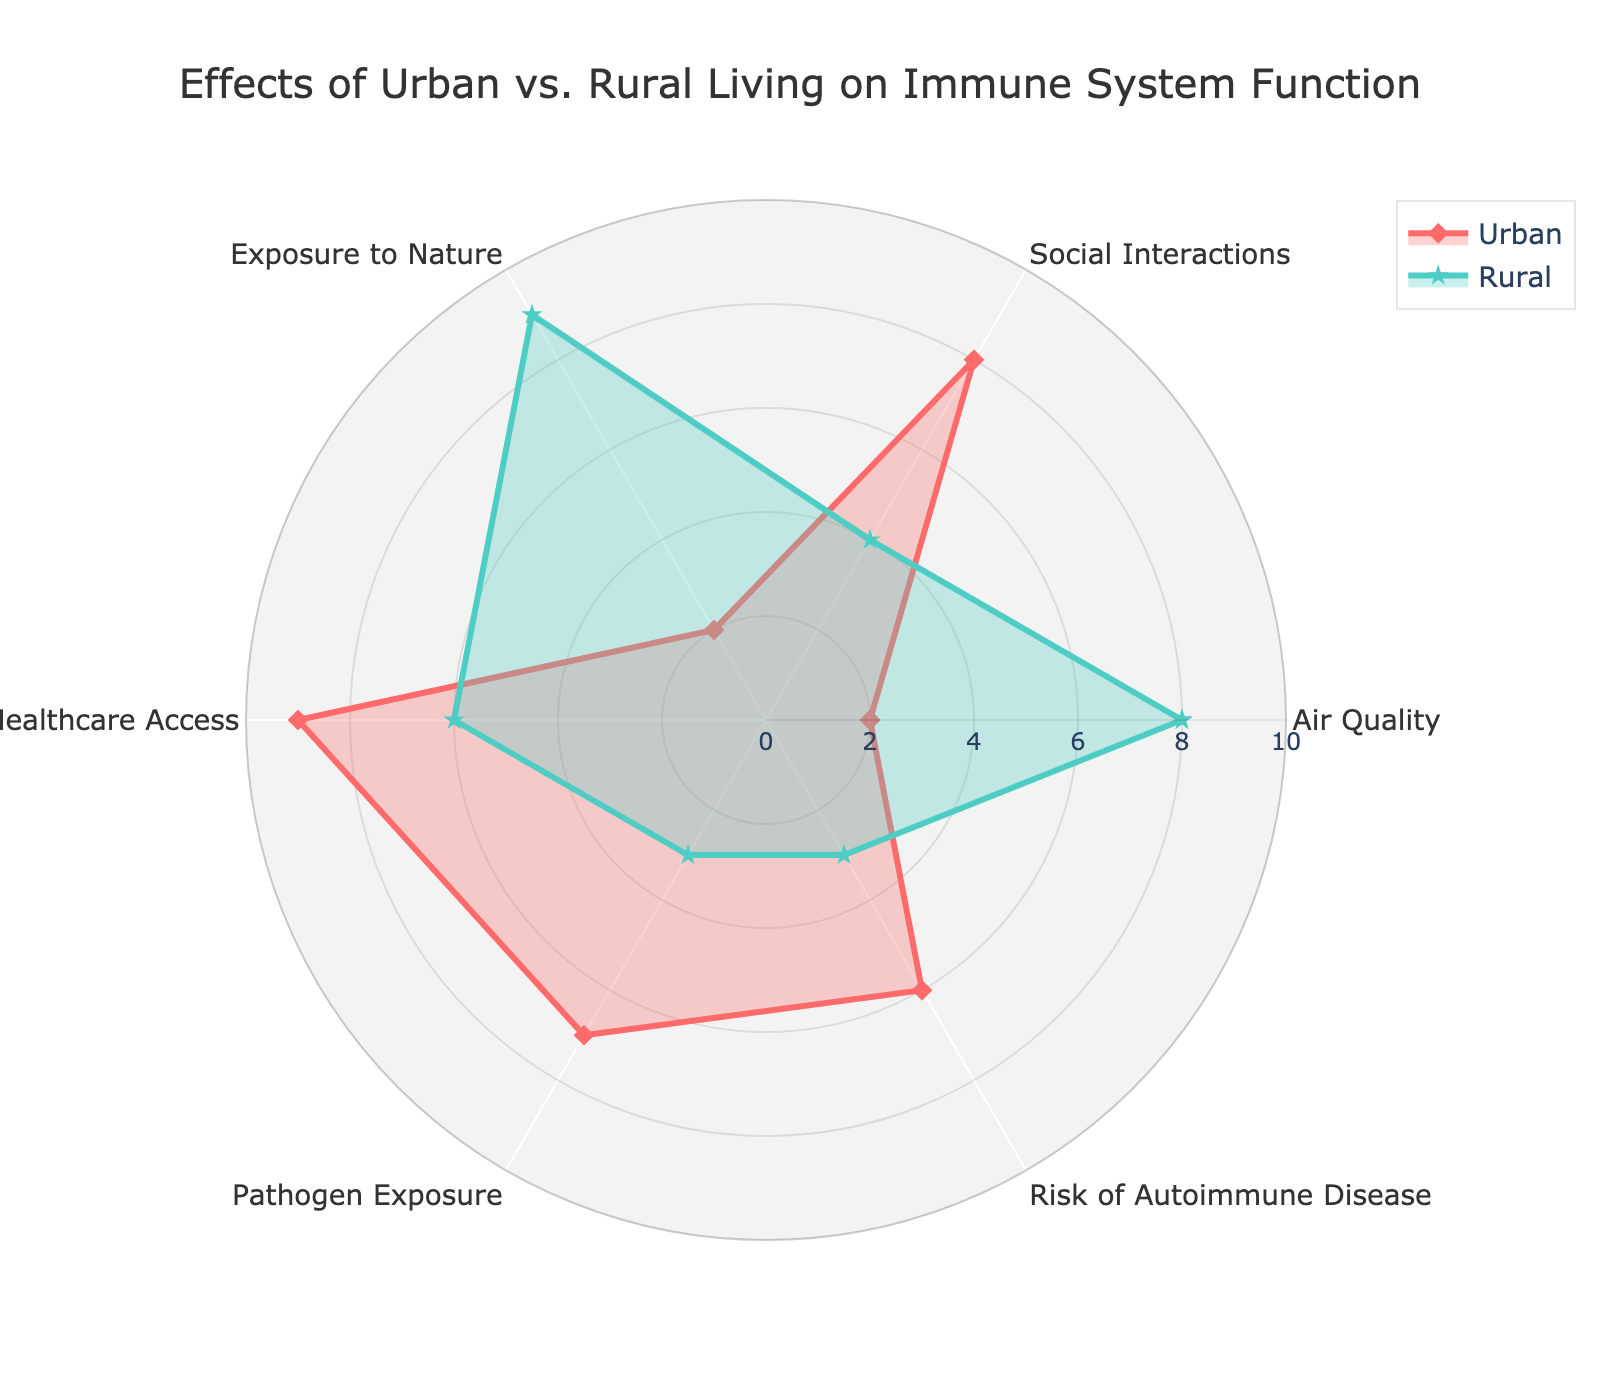What is the title of the figure? The title is usually displayed at the top of the figure. It summarizes the main topic or purpose of the chart.
Answer: Effects of Urban vs. Rural Living on Immune System Function What color is used to represent the 'Urban' group? The 'Urban' group is represented using a distinct color to differentiate it from the 'Rural' group.
Answer: Red Which group has a higher "Exposure to Nature" value? Compare the "Exposure to Nature" values between the urban and rural groups.
Answer: Rural What is the difference in "Air Quality" ratings between Urban and Rural areas? Subtract the "Air Quality" rating of the Urban group from the Rural group. The computation is 8 (Rural) - 2 (Urban).
Answer: 6 Considering 'Healthcare Access', which group fares better and by how much? Compare the 'Healthcare Access' ratings between the two groups and compute the difference. Urban: 9, Rural: 6. The difference is 9 - 6.
Answer: Urban by 3 Calculate the average value of "Social Interactions" for both groups combined. Sum the "Social Interactions" values for both groups (8 for Urban and 4 for Rural) and divide by 2. (8+4)/2 = 6.
Answer: 6 Which attribute shows the largest difference between Urban and Rural ratings? Identify which attribute has the greatest absolute difference between Urban and Rural values.
Answer: Exposure to Nature Are there any attributes where the Urban and Rural ratings are equal? Review the values for each attribute and check for equality between Urban and Rural groups.
Answer: No How is the 'Risk of Autoimmune Disease' different between Urban and Rural groups? Compare the values for 'Risk of Autoimmune Disease' in both groups. Urban: 6, Rural: 3, so 6 - 3.
Answer: 3 units higher in Urban 